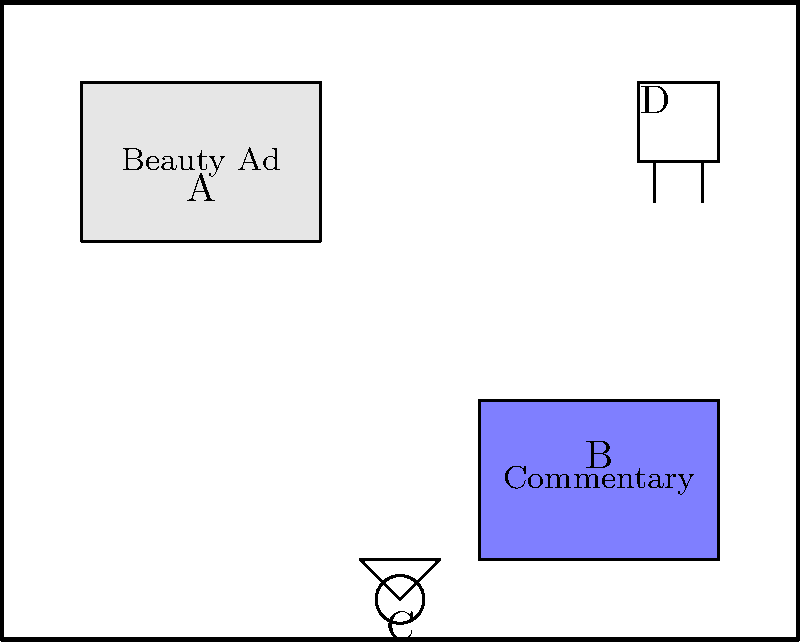As a film critic planning a set to critique unrealistic beauty standards, you need to arrange elements to create a powerful visual message. In the diagram, which spatial arrangement would best emphasize the contrast between harmful beauty ideals and critical commentary? To answer this question, we need to consider the spatial relationships between the elements and their symbolic meanings:

1. Element A represents an unrealistic beauty standard billboard, positioned prominently in the upper left corner of the set.
2. Element B represents the critical commentary area, located in the lower right corner.
3. Element C is the camera, positioned centrally at the bottom of the set.
4. Element D is the director's chair, placed in the upper right corner.

The most effective arrangement to emphasize the contrast between harmful beauty ideals and critical commentary would be:

1. Keep the beauty ad (A) and critical commentary area (B) as far apart as possible to create a visual tension.
2. Position the camera (C) to capture both elements in the same frame, allowing for a visual comparison.
3. Place the director's chair (D) closer to the critical commentary area to symbolize the filmmaker's alignment with the critique.

This arrangement creates a diagonal line of sight from A to B, with C positioned to capture this contrast. The current layout in the diagram achieves this effect by:

1. Placing A in the upper left and B in the lower right, maximizing the distance between them.
2. Positioning C centrally, able to capture both A and B in its field of view.
3. Locating D closer to B than to A, suggesting the director's critical stance.

Therefore, the current spatial arrangement in the diagram is the most effective for emphasizing the contrast between harmful beauty ideals and critical commentary.
Answer: The current arrangement 